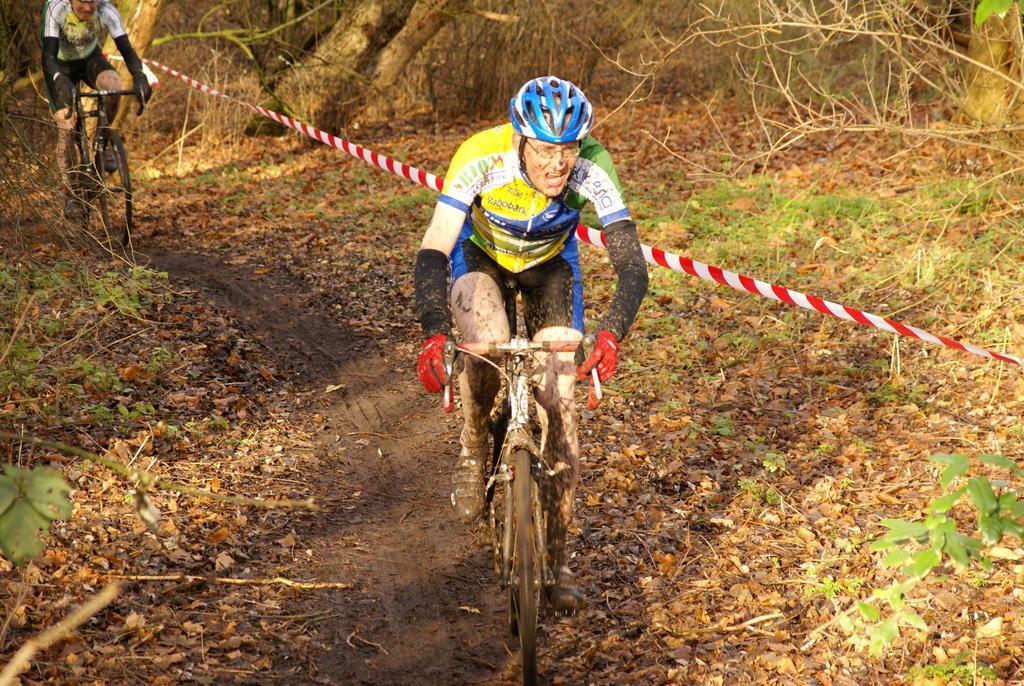In one or two sentences, can you explain what this image depicts? In the image I can see two people wearing helmets and riding the bicycles and around there are some plants, dry leaves and a rope to the side. 